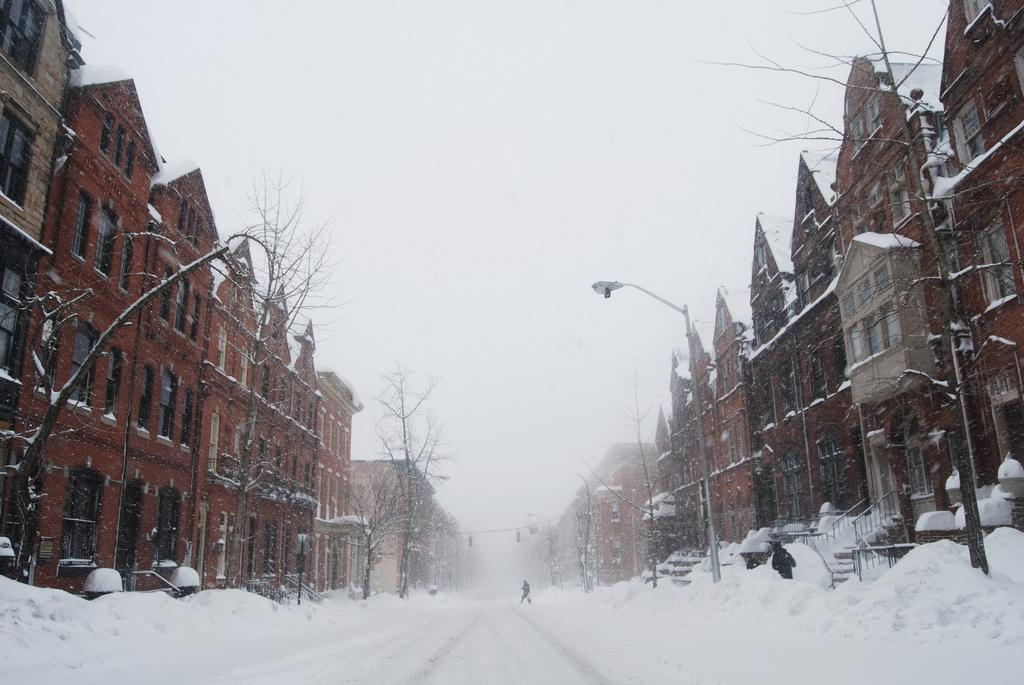What type of structures can be seen in the image? There are buildings in the image. What is the purpose of the object with a light on top? There is a street light in the image, which provides illumination. What weather condition is depicted in the image? There is snow visible in the image. Can you describe the background of the image? There is a person and the sky visible in the background of the image. What type of voice can be heard coming from the person in the background of the image? There is no indication of any sound or voice in the image, as it is a still photograph. What type of laborer is working on the buildings in the image? There is no laborer or construction work depicted in the image; it only shows buildings, a street light, snow, and a person in the background. 